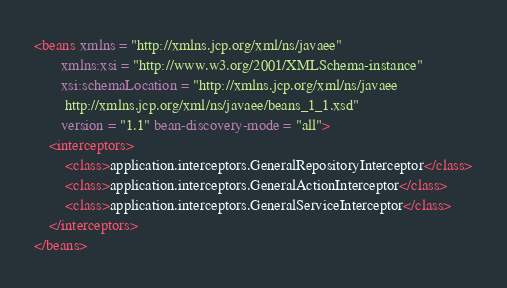<code> <loc_0><loc_0><loc_500><loc_500><_XML_><beans xmlns = "http://xmlns.jcp.org/xml/ns/javaee"
       xmlns:xsi = "http://www.w3.org/2001/XMLSchema-instance"
       xsi:schemaLocation = "http://xmlns.jcp.org/xml/ns/javaee
        http://xmlns.jcp.org/xml/ns/javaee/beans_1_1.xsd"
       version = "1.1" bean-discovery-mode = "all">
    <interceptors>
        <class>application.interceptors.GeneralRepositoryInterceptor</class>
        <class>application.interceptors.GeneralActionInterceptor</class>
        <class>application.interceptors.GeneralServiceInterceptor</class>
    </interceptors>
</beans></code> 